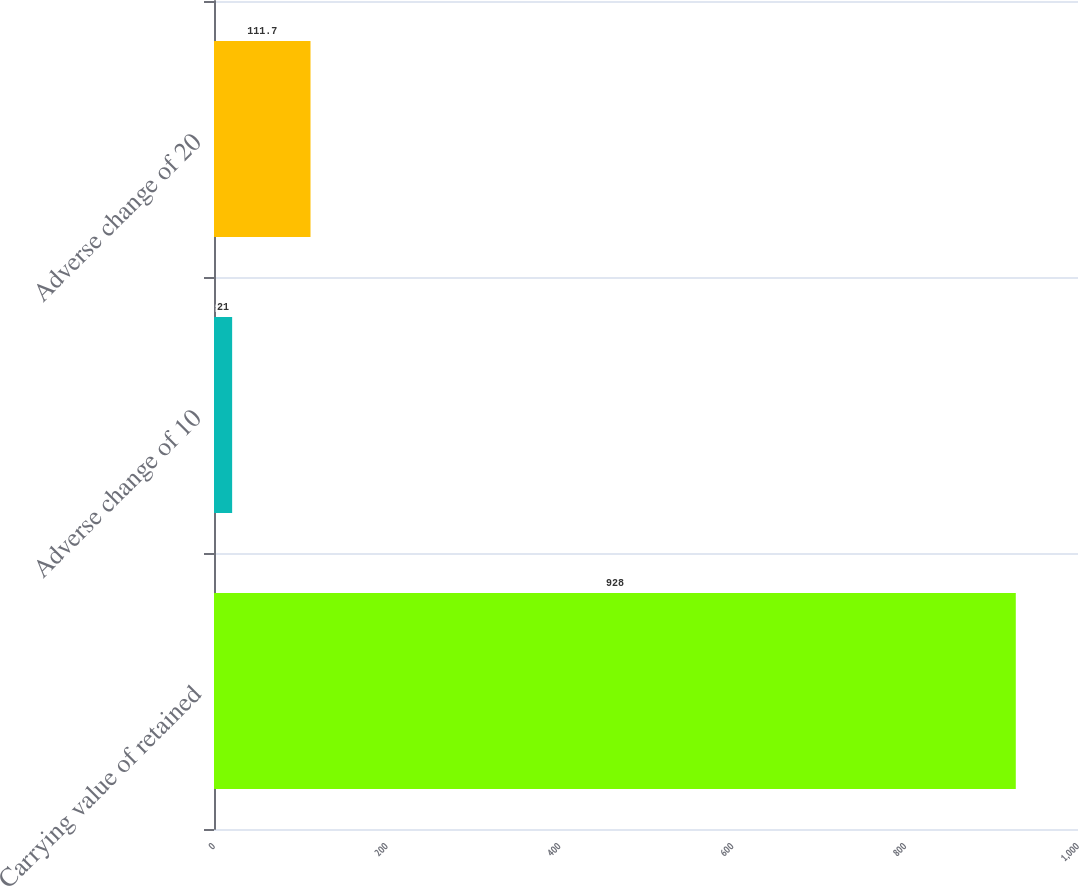Convert chart. <chart><loc_0><loc_0><loc_500><loc_500><bar_chart><fcel>Carrying value of retained<fcel>Adverse change of 10<fcel>Adverse change of 20<nl><fcel>928<fcel>21<fcel>111.7<nl></chart> 